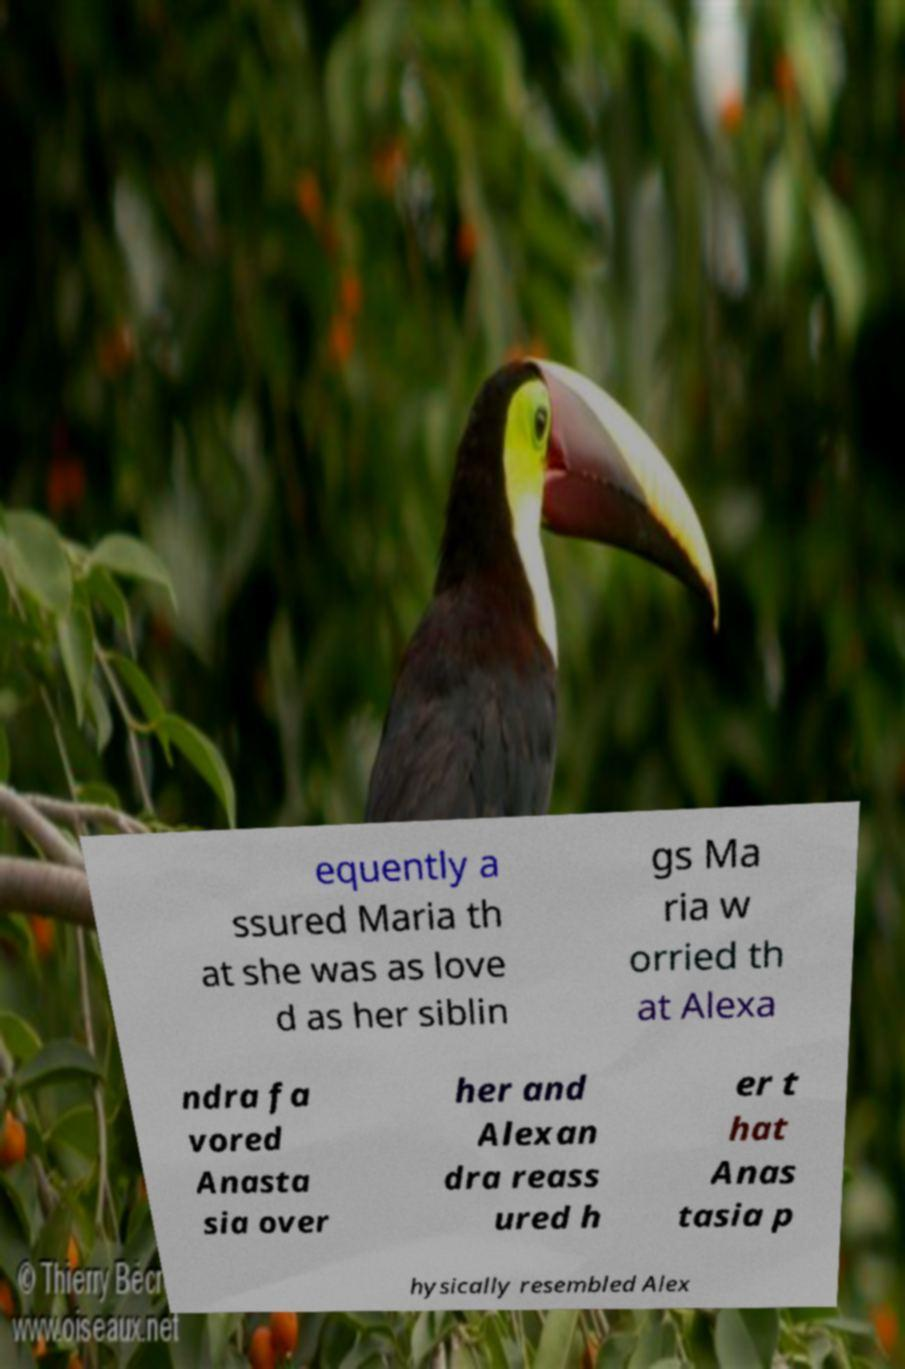What messages or text are displayed in this image? I need them in a readable, typed format. equently a ssured Maria th at she was as love d as her siblin gs Ma ria w orried th at Alexa ndra fa vored Anasta sia over her and Alexan dra reass ured h er t hat Anas tasia p hysically resembled Alex 